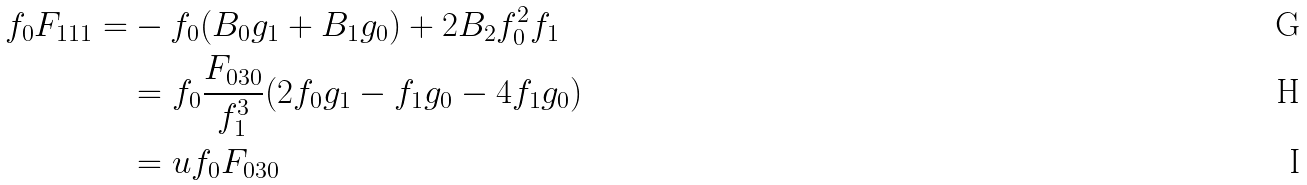<formula> <loc_0><loc_0><loc_500><loc_500>f _ { 0 } F _ { 1 1 1 } = & - f _ { 0 } ( B _ { 0 } g _ { 1 } + B _ { 1 } g _ { 0 } ) + 2 B _ { 2 } f _ { 0 } ^ { 2 } f _ { 1 } \\ & = f _ { 0 } \frac { F _ { 0 3 0 } } { f _ { 1 } ^ { 3 } } ( 2 f _ { 0 } g _ { 1 } - f _ { 1 } g _ { 0 } - 4 f _ { 1 } g _ { 0 } ) \\ & = u f _ { 0 } F _ { 0 3 0 }</formula> 